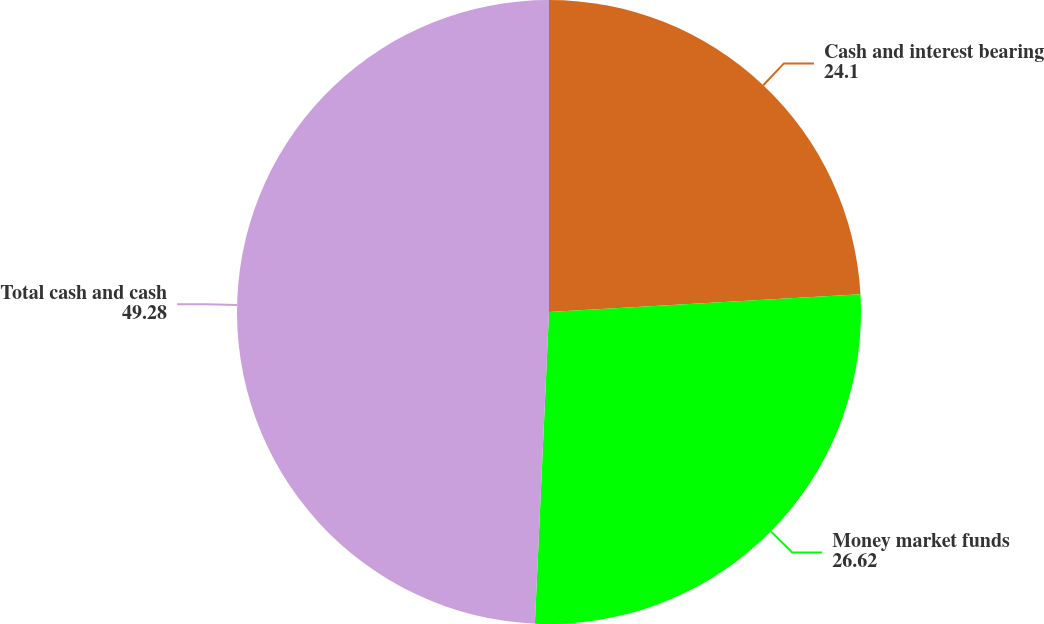Convert chart to OTSL. <chart><loc_0><loc_0><loc_500><loc_500><pie_chart><fcel>Cash and interest bearing<fcel>Money market funds<fcel>Total cash and cash<nl><fcel>24.1%<fcel>26.62%<fcel>49.28%<nl></chart> 